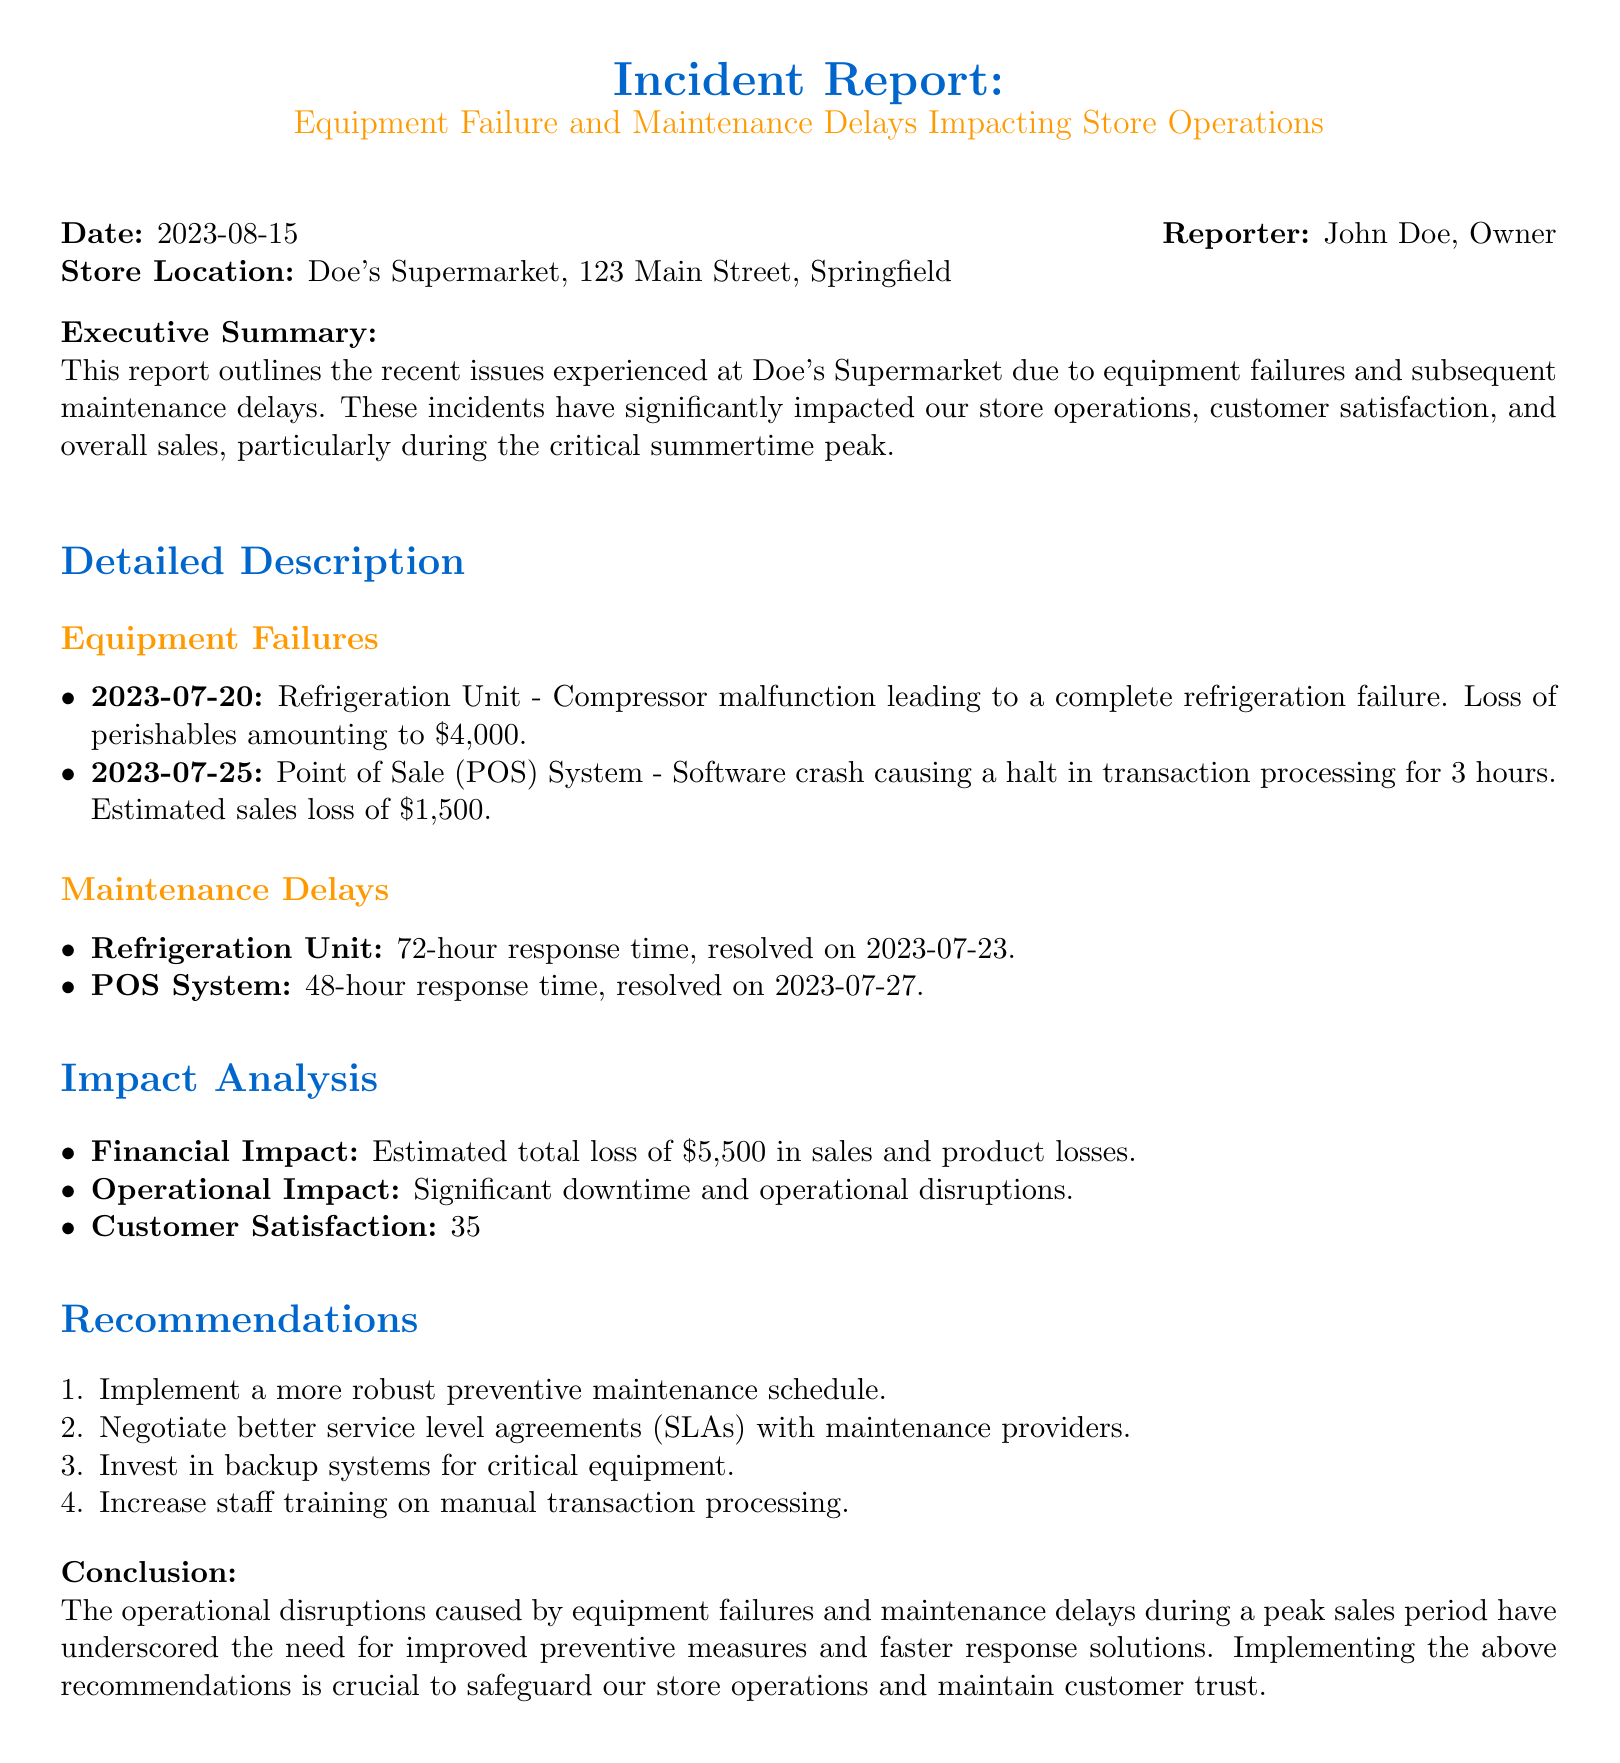What is the date of the incident report? The date of the incident report is mentioned as 2023-08-15.
Answer: 2023-08-15 Who reported the incident? The incident report states that it was reported by John Doe, the owner.
Answer: John Doe How much was the loss of perishables due to refrigeration failure? The report details that the loss of perishables amounted to $4,000 due to the refrigeration failure.
Answer: $4,000 What was the estimated sales loss due to the POS system crash? The estimated sales loss caused by the POS system crash was $1,500.
Answer: $1,500 What was the impact on customer complaints? The report indicates a 35% increase in customer complaints.
Answer: 35% What was the response time for the refrigeration unit maintenance? The response time for the refrigeration unit maintenance was 72 hours.
Answer: 72 hours What is one of the recommendations provided in the report? The report includes several recommendations, one being to implement a more robust preventive maintenance schedule.
Answer: Implement a more robust preventive maintenance schedule What is the total estimated loss mentioned in the report? The total estimated loss of sales and product losses in the report is $5,500.
Answer: $5,500 What type of system failure caused a 3-hour transaction halt? The document specifies that the POS system experienced a software crash, causing a halt in transactions.
Answer: POS System 